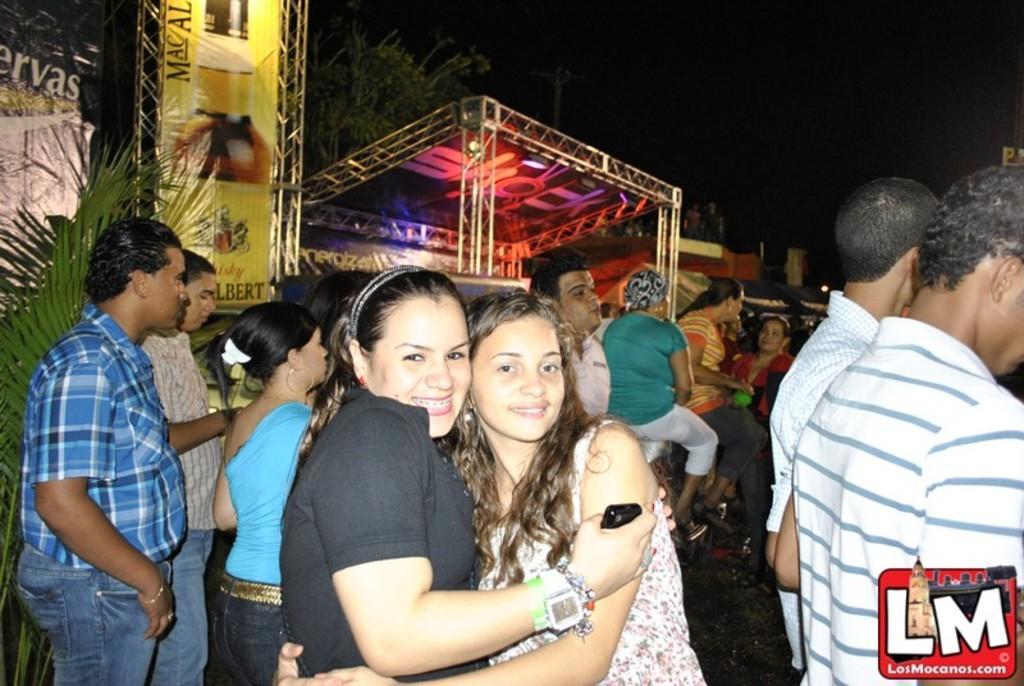Could you give a brief overview of what you see in this image? In this image I can see the group of people with different color dresses. To the side I can see the banner and the stage. In the background there are many trees and the sky. 